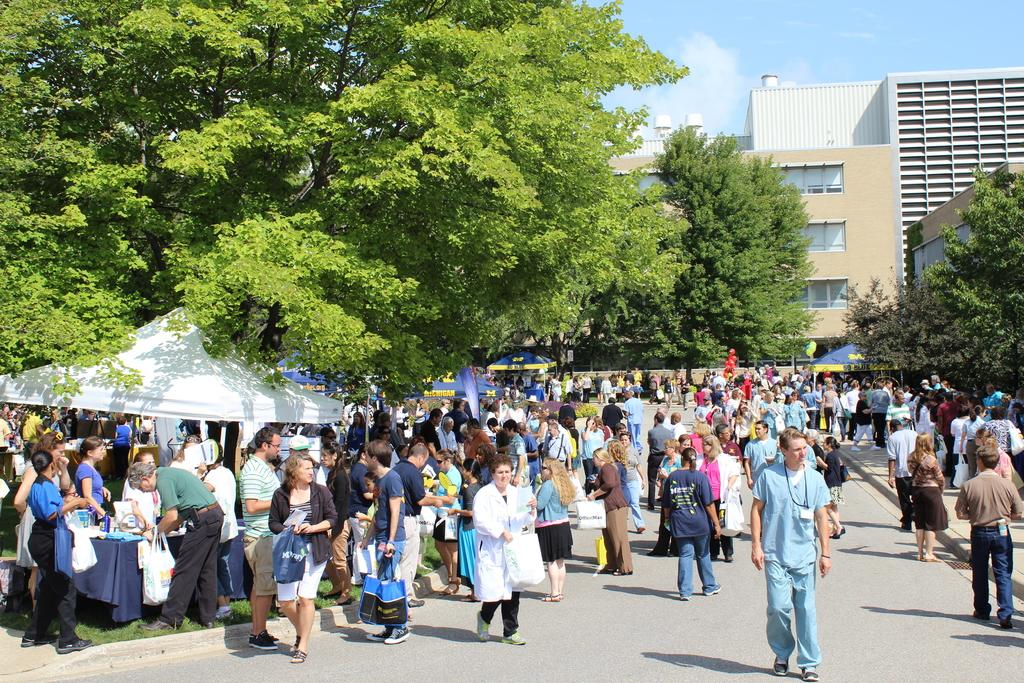What are the people in the image doing? The people in the image are walking. What can be seen on the left side of the image? There are tents on the left side of the image. What type of vegetation is present in the image? There are trees in the image. What is visible in the background of the image? There is a building and the sky visible in the background of the image. What is at the bottom of the image? There is a road at the bottom of the image. How many planes can be seen flying in the image? There are no planes visible in the image. What type of connection is established between the tents and the trees in the image? There is no connection established between the tents and the trees in the image; they are separate elements. 